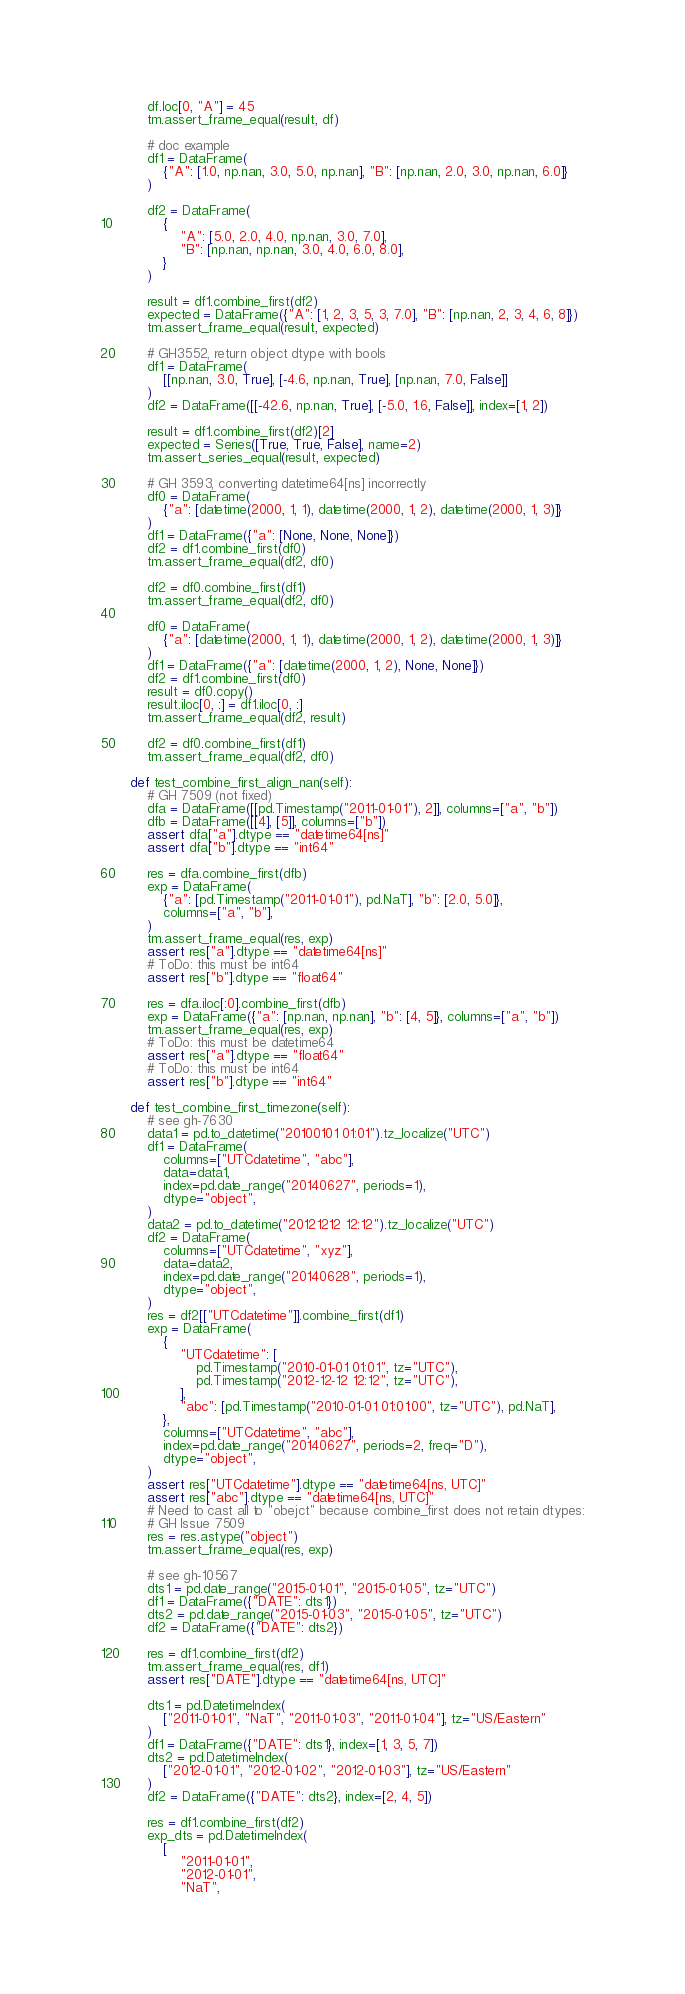<code> <loc_0><loc_0><loc_500><loc_500><_Python_>        df.loc[0, "A"] = 45
        tm.assert_frame_equal(result, df)

        # doc example
        df1 = DataFrame(
            {"A": [1.0, np.nan, 3.0, 5.0, np.nan], "B": [np.nan, 2.0, 3.0, np.nan, 6.0]}
        )

        df2 = DataFrame(
            {
                "A": [5.0, 2.0, 4.0, np.nan, 3.0, 7.0],
                "B": [np.nan, np.nan, 3.0, 4.0, 6.0, 8.0],
            }
        )

        result = df1.combine_first(df2)
        expected = DataFrame({"A": [1, 2, 3, 5, 3, 7.0], "B": [np.nan, 2, 3, 4, 6, 8]})
        tm.assert_frame_equal(result, expected)

        # GH3552, return object dtype with bools
        df1 = DataFrame(
            [[np.nan, 3.0, True], [-4.6, np.nan, True], [np.nan, 7.0, False]]
        )
        df2 = DataFrame([[-42.6, np.nan, True], [-5.0, 1.6, False]], index=[1, 2])

        result = df1.combine_first(df2)[2]
        expected = Series([True, True, False], name=2)
        tm.assert_series_equal(result, expected)

        # GH 3593, converting datetime64[ns] incorrectly
        df0 = DataFrame(
            {"a": [datetime(2000, 1, 1), datetime(2000, 1, 2), datetime(2000, 1, 3)]}
        )
        df1 = DataFrame({"a": [None, None, None]})
        df2 = df1.combine_first(df0)
        tm.assert_frame_equal(df2, df0)

        df2 = df0.combine_first(df1)
        tm.assert_frame_equal(df2, df0)

        df0 = DataFrame(
            {"a": [datetime(2000, 1, 1), datetime(2000, 1, 2), datetime(2000, 1, 3)]}
        )
        df1 = DataFrame({"a": [datetime(2000, 1, 2), None, None]})
        df2 = df1.combine_first(df0)
        result = df0.copy()
        result.iloc[0, :] = df1.iloc[0, :]
        tm.assert_frame_equal(df2, result)

        df2 = df0.combine_first(df1)
        tm.assert_frame_equal(df2, df0)

    def test_combine_first_align_nan(self):
        # GH 7509 (not fixed)
        dfa = DataFrame([[pd.Timestamp("2011-01-01"), 2]], columns=["a", "b"])
        dfb = DataFrame([[4], [5]], columns=["b"])
        assert dfa["a"].dtype == "datetime64[ns]"
        assert dfa["b"].dtype == "int64"

        res = dfa.combine_first(dfb)
        exp = DataFrame(
            {"a": [pd.Timestamp("2011-01-01"), pd.NaT], "b": [2.0, 5.0]},
            columns=["a", "b"],
        )
        tm.assert_frame_equal(res, exp)
        assert res["a"].dtype == "datetime64[ns]"
        # ToDo: this must be int64
        assert res["b"].dtype == "float64"

        res = dfa.iloc[:0].combine_first(dfb)
        exp = DataFrame({"a": [np.nan, np.nan], "b": [4, 5]}, columns=["a", "b"])
        tm.assert_frame_equal(res, exp)
        # ToDo: this must be datetime64
        assert res["a"].dtype == "float64"
        # ToDo: this must be int64
        assert res["b"].dtype == "int64"

    def test_combine_first_timezone(self):
        # see gh-7630
        data1 = pd.to_datetime("20100101 01:01").tz_localize("UTC")
        df1 = DataFrame(
            columns=["UTCdatetime", "abc"],
            data=data1,
            index=pd.date_range("20140627", periods=1),
            dtype="object",
        )
        data2 = pd.to_datetime("20121212 12:12").tz_localize("UTC")
        df2 = DataFrame(
            columns=["UTCdatetime", "xyz"],
            data=data2,
            index=pd.date_range("20140628", periods=1),
            dtype="object",
        )
        res = df2[["UTCdatetime"]].combine_first(df1)
        exp = DataFrame(
            {
                "UTCdatetime": [
                    pd.Timestamp("2010-01-01 01:01", tz="UTC"),
                    pd.Timestamp("2012-12-12 12:12", tz="UTC"),
                ],
                "abc": [pd.Timestamp("2010-01-01 01:01:00", tz="UTC"), pd.NaT],
            },
            columns=["UTCdatetime", "abc"],
            index=pd.date_range("20140627", periods=2, freq="D"),
            dtype="object",
        )
        assert res["UTCdatetime"].dtype == "datetime64[ns, UTC]"
        assert res["abc"].dtype == "datetime64[ns, UTC]"
        # Need to cast all to "obejct" because combine_first does not retain dtypes:
        # GH Issue 7509
        res = res.astype("object")
        tm.assert_frame_equal(res, exp)

        # see gh-10567
        dts1 = pd.date_range("2015-01-01", "2015-01-05", tz="UTC")
        df1 = DataFrame({"DATE": dts1})
        dts2 = pd.date_range("2015-01-03", "2015-01-05", tz="UTC")
        df2 = DataFrame({"DATE": dts2})

        res = df1.combine_first(df2)
        tm.assert_frame_equal(res, df1)
        assert res["DATE"].dtype == "datetime64[ns, UTC]"

        dts1 = pd.DatetimeIndex(
            ["2011-01-01", "NaT", "2011-01-03", "2011-01-04"], tz="US/Eastern"
        )
        df1 = DataFrame({"DATE": dts1}, index=[1, 3, 5, 7])
        dts2 = pd.DatetimeIndex(
            ["2012-01-01", "2012-01-02", "2012-01-03"], tz="US/Eastern"
        )
        df2 = DataFrame({"DATE": dts2}, index=[2, 4, 5])

        res = df1.combine_first(df2)
        exp_dts = pd.DatetimeIndex(
            [
                "2011-01-01",
                "2012-01-01",
                "NaT",</code> 